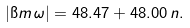Convert formula to latex. <formula><loc_0><loc_0><loc_500><loc_500>| \i m \, \omega | = 4 8 . 4 7 + 4 8 . 0 0 \, n .</formula> 